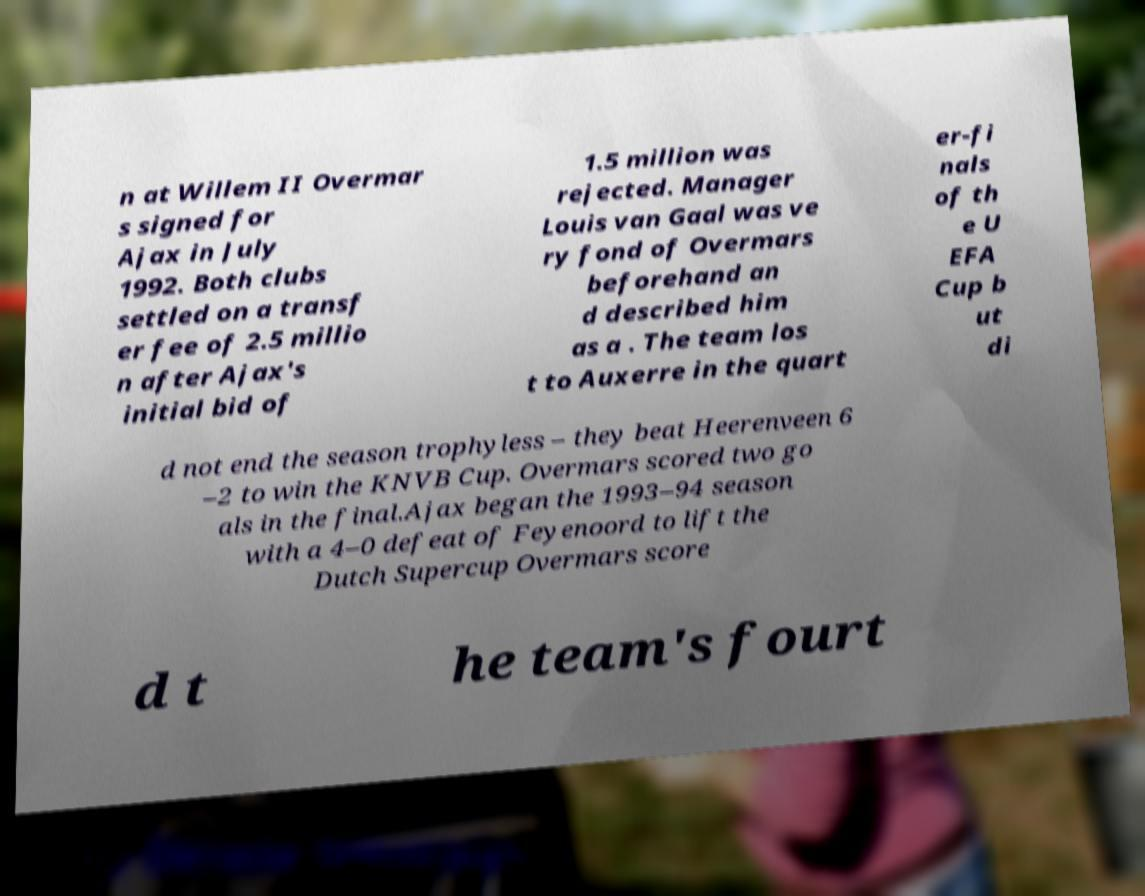Please identify and transcribe the text found in this image. n at Willem II Overmar s signed for Ajax in July 1992. Both clubs settled on a transf er fee of 2.5 millio n after Ajax's initial bid of 1.5 million was rejected. Manager Louis van Gaal was ve ry fond of Overmars beforehand an d described him as a . The team los t to Auxerre in the quart er-fi nals of th e U EFA Cup b ut di d not end the season trophyless – they beat Heerenveen 6 –2 to win the KNVB Cup. Overmars scored two go als in the final.Ajax began the 1993–94 season with a 4–0 defeat of Feyenoord to lift the Dutch Supercup Overmars score d t he team's fourt 